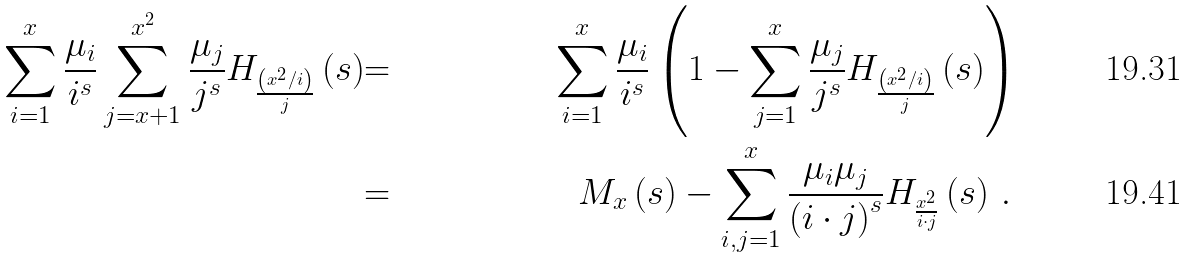<formula> <loc_0><loc_0><loc_500><loc_500>{ \sum _ { i = 1 } ^ { x } \frac { \mu _ { i } } { i ^ { s } } \sum _ { j = x + 1 } ^ { x ^ { 2 } } \frac { \mu _ { j } } { j ^ { s } } H _ { \frac { \left ( x ^ { 2 } / i \right ) } { j } } \left ( s \right ) } & { = } & { \sum _ { i = 1 } ^ { x } \frac { \mu _ { i } } { i ^ { s } } \left ( 1 - \sum _ { j = 1 } ^ { x } \frac { \mu _ { j } } { j ^ { s } } H _ { \frac { \left ( x ^ { 2 } / i \right ) } { j } } \left ( s \right ) \right ) } \\ { \quad } & { = } & { M _ { x } \left ( s \right ) - \sum _ { i , j = 1 } ^ { x } \frac { \mu _ { i } \mu _ { j } } { \left ( i \cdot j \right ) ^ { s } } H _ { \frac { x ^ { 2 } } { i \cdot j } } \left ( s \right ) \, . \, }</formula> 